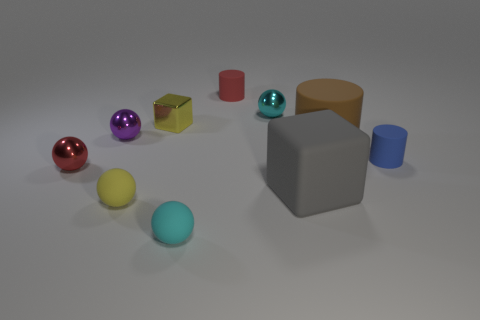Subtract all yellow balls. How many balls are left? 4 Subtract all tiny cyan rubber balls. How many balls are left? 4 Subtract all blue balls. Subtract all brown cubes. How many balls are left? 5 Subtract all cylinders. How many objects are left? 7 Add 3 red spheres. How many red spheres are left? 4 Add 8 large metal spheres. How many large metal spheres exist? 8 Subtract 1 red balls. How many objects are left? 9 Subtract all yellow spheres. Subtract all blocks. How many objects are left? 7 